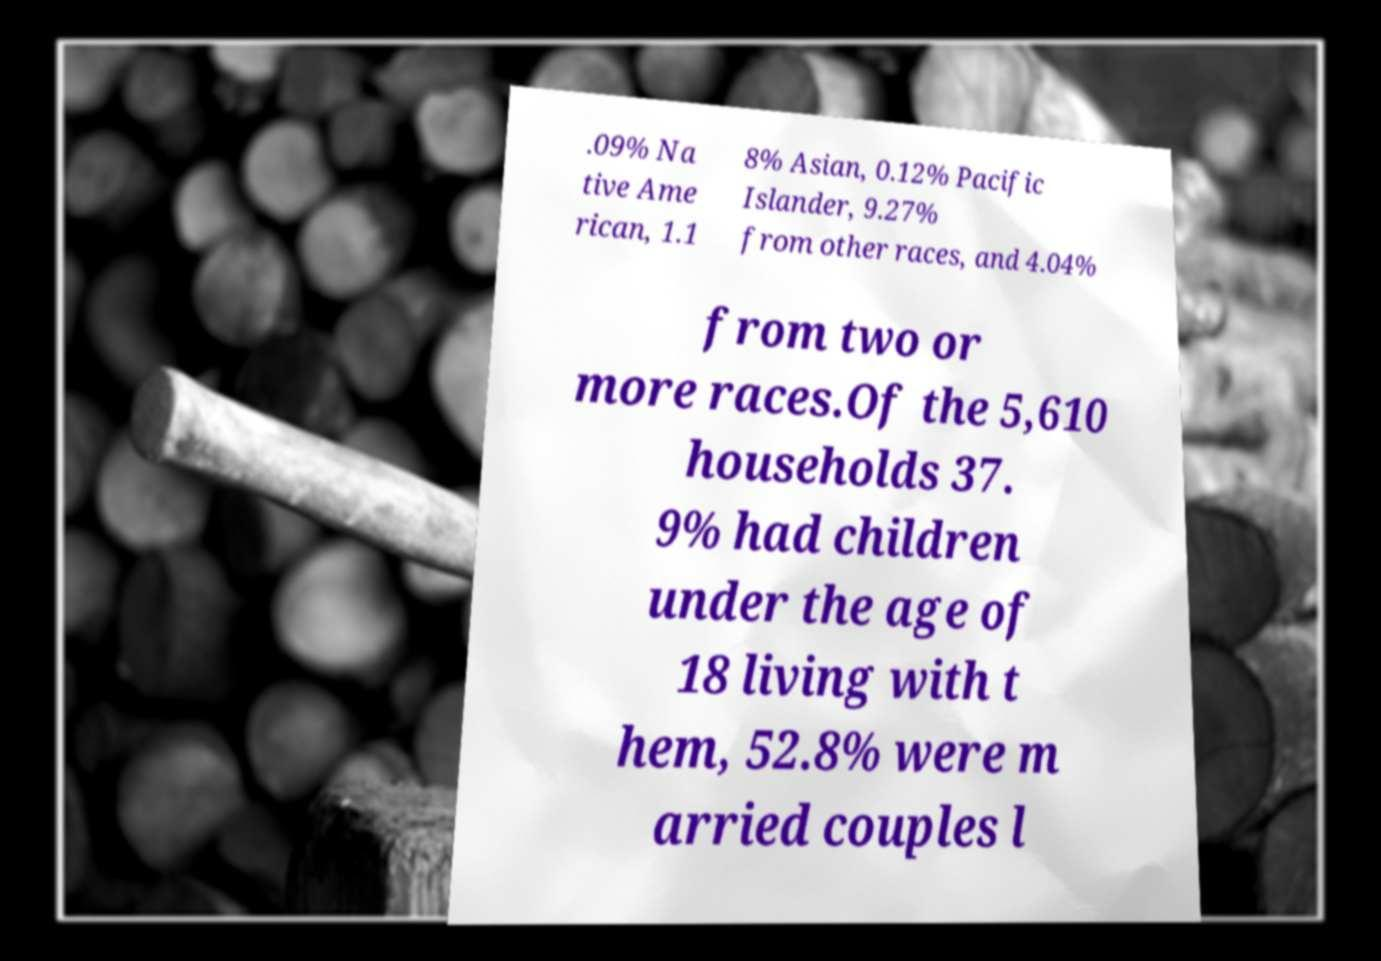What messages or text are displayed in this image? I need them in a readable, typed format. .09% Na tive Ame rican, 1.1 8% Asian, 0.12% Pacific Islander, 9.27% from other races, and 4.04% from two or more races.Of the 5,610 households 37. 9% had children under the age of 18 living with t hem, 52.8% were m arried couples l 